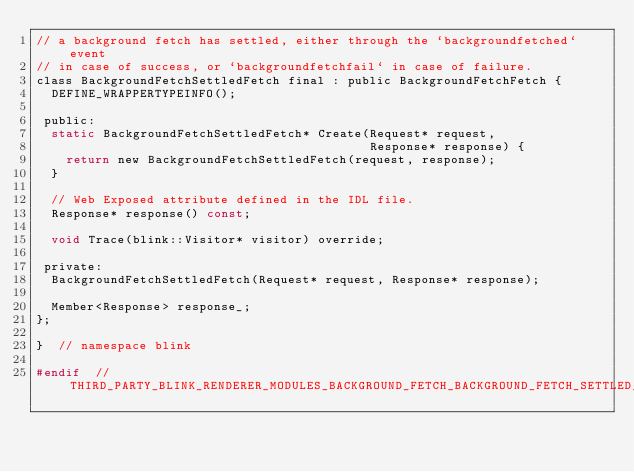<code> <loc_0><loc_0><loc_500><loc_500><_C_>// a background fetch has settled, either through the `backgroundfetched` event
// in case of success, or `backgroundfetchfail` in case of failure.
class BackgroundFetchSettledFetch final : public BackgroundFetchFetch {
  DEFINE_WRAPPERTYPEINFO();

 public:
  static BackgroundFetchSettledFetch* Create(Request* request,
                                             Response* response) {
    return new BackgroundFetchSettledFetch(request, response);
  }

  // Web Exposed attribute defined in the IDL file.
  Response* response() const;

  void Trace(blink::Visitor* visitor) override;

 private:
  BackgroundFetchSettledFetch(Request* request, Response* response);

  Member<Response> response_;
};

}  // namespace blink

#endif  // THIRD_PARTY_BLINK_RENDERER_MODULES_BACKGROUND_FETCH_BACKGROUND_FETCH_SETTLED_FETCH_H_
</code> 